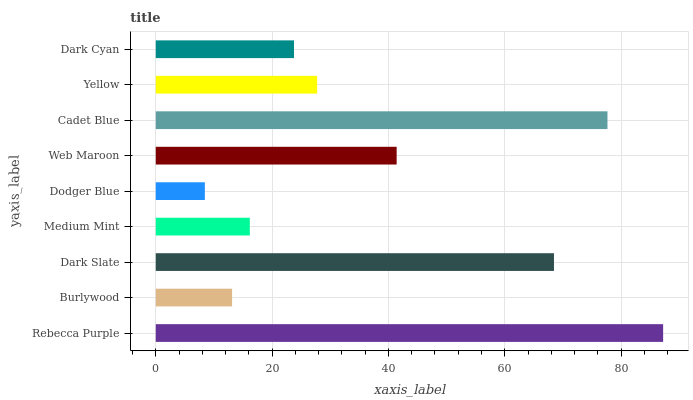Is Dodger Blue the minimum?
Answer yes or no. Yes. Is Rebecca Purple the maximum?
Answer yes or no. Yes. Is Burlywood the minimum?
Answer yes or no. No. Is Burlywood the maximum?
Answer yes or no. No. Is Rebecca Purple greater than Burlywood?
Answer yes or no. Yes. Is Burlywood less than Rebecca Purple?
Answer yes or no. Yes. Is Burlywood greater than Rebecca Purple?
Answer yes or no. No. Is Rebecca Purple less than Burlywood?
Answer yes or no. No. Is Yellow the high median?
Answer yes or no. Yes. Is Yellow the low median?
Answer yes or no. Yes. Is Medium Mint the high median?
Answer yes or no. No. Is Dark Slate the low median?
Answer yes or no. No. 